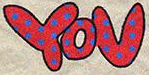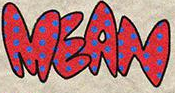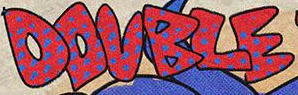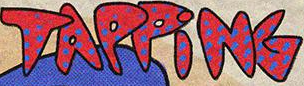Identify the words shown in these images in order, separated by a semicolon. YOU; MEAN; DOUBLE; TAPPiNG 